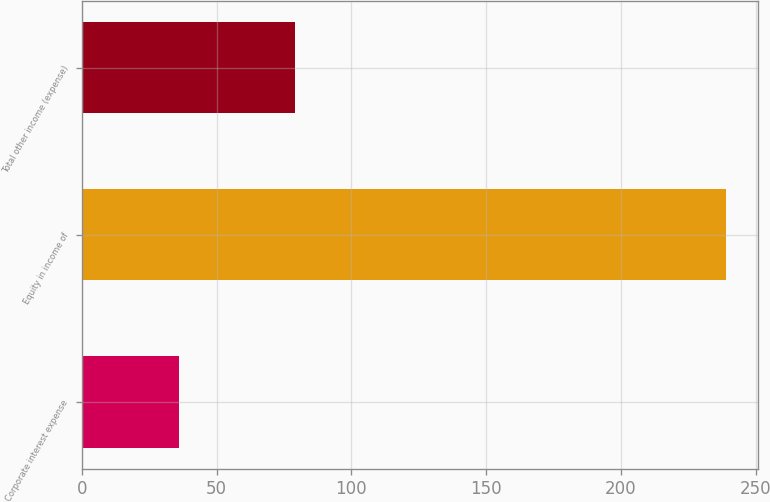<chart> <loc_0><loc_0><loc_500><loc_500><bar_chart><fcel>Corporate interest expense<fcel>Equity in income of<fcel>Total other income (expense)<nl><fcel>36<fcel>239<fcel>79<nl></chart> 